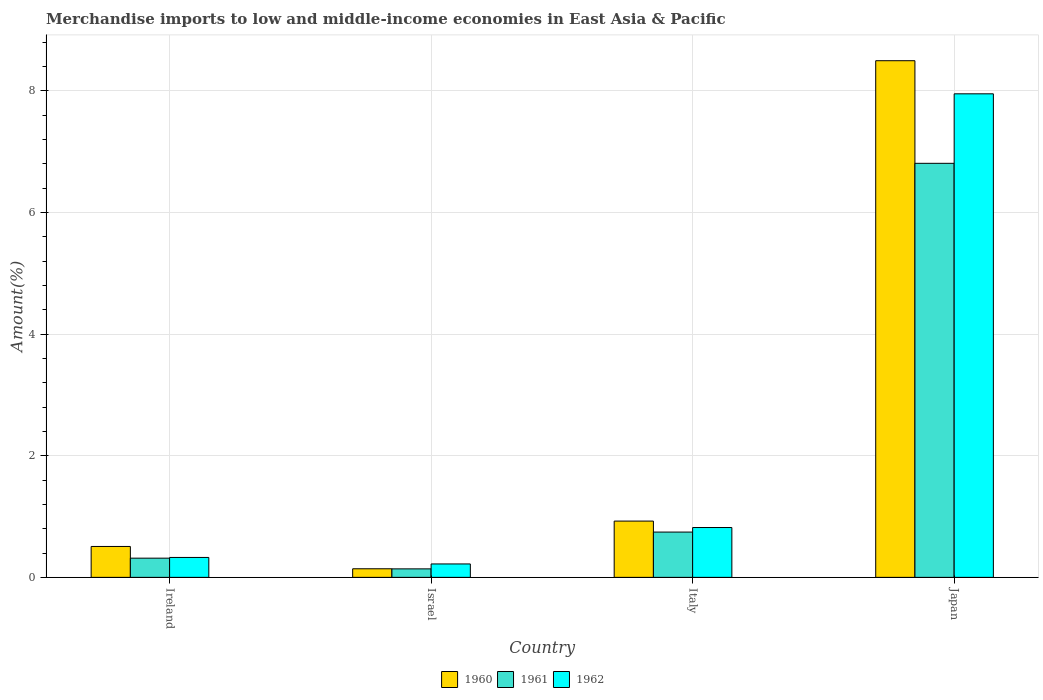How many groups of bars are there?
Offer a terse response. 4. Are the number of bars per tick equal to the number of legend labels?
Your answer should be compact. Yes. How many bars are there on the 4th tick from the left?
Offer a very short reply. 3. How many bars are there on the 1st tick from the right?
Offer a terse response. 3. What is the label of the 1st group of bars from the left?
Offer a terse response. Ireland. In how many cases, is the number of bars for a given country not equal to the number of legend labels?
Offer a terse response. 0. What is the percentage of amount earned from merchandise imports in 1962 in Japan?
Provide a succinct answer. 7.95. Across all countries, what is the maximum percentage of amount earned from merchandise imports in 1962?
Make the answer very short. 7.95. Across all countries, what is the minimum percentage of amount earned from merchandise imports in 1962?
Provide a succinct answer. 0.22. In which country was the percentage of amount earned from merchandise imports in 1961 maximum?
Provide a short and direct response. Japan. What is the total percentage of amount earned from merchandise imports in 1961 in the graph?
Give a very brief answer. 8.01. What is the difference between the percentage of amount earned from merchandise imports in 1962 in Ireland and that in Israel?
Give a very brief answer. 0.11. What is the difference between the percentage of amount earned from merchandise imports in 1960 in Ireland and the percentage of amount earned from merchandise imports in 1961 in Italy?
Give a very brief answer. -0.24. What is the average percentage of amount earned from merchandise imports in 1961 per country?
Ensure brevity in your answer.  2. What is the difference between the percentage of amount earned from merchandise imports of/in 1962 and percentage of amount earned from merchandise imports of/in 1960 in Japan?
Make the answer very short. -0.54. What is the ratio of the percentage of amount earned from merchandise imports in 1960 in Ireland to that in Japan?
Your response must be concise. 0.06. Is the percentage of amount earned from merchandise imports in 1960 in Ireland less than that in Japan?
Provide a succinct answer. Yes. What is the difference between the highest and the second highest percentage of amount earned from merchandise imports in 1961?
Your response must be concise. 0.43. What is the difference between the highest and the lowest percentage of amount earned from merchandise imports in 1961?
Ensure brevity in your answer.  6.67. Is the sum of the percentage of amount earned from merchandise imports in 1960 in Ireland and Japan greater than the maximum percentage of amount earned from merchandise imports in 1962 across all countries?
Ensure brevity in your answer.  Yes. What does the 1st bar from the left in Japan represents?
Provide a succinct answer. 1960. Are all the bars in the graph horizontal?
Give a very brief answer. No. Does the graph contain any zero values?
Give a very brief answer. No. How many legend labels are there?
Keep it short and to the point. 3. How are the legend labels stacked?
Provide a short and direct response. Horizontal. What is the title of the graph?
Your answer should be compact. Merchandise imports to low and middle-income economies in East Asia & Pacific. What is the label or title of the X-axis?
Your answer should be compact. Country. What is the label or title of the Y-axis?
Provide a succinct answer. Amount(%). What is the Amount(%) of 1960 in Ireland?
Keep it short and to the point. 0.51. What is the Amount(%) of 1961 in Ireland?
Offer a terse response. 0.32. What is the Amount(%) of 1962 in Ireland?
Ensure brevity in your answer.  0.33. What is the Amount(%) of 1960 in Israel?
Provide a short and direct response. 0.14. What is the Amount(%) of 1961 in Israel?
Provide a short and direct response. 0.14. What is the Amount(%) in 1962 in Israel?
Offer a very short reply. 0.22. What is the Amount(%) in 1960 in Italy?
Your answer should be very brief. 0.93. What is the Amount(%) of 1961 in Italy?
Provide a short and direct response. 0.74. What is the Amount(%) in 1962 in Italy?
Make the answer very short. 0.82. What is the Amount(%) in 1960 in Japan?
Offer a terse response. 8.5. What is the Amount(%) in 1961 in Japan?
Offer a terse response. 6.81. What is the Amount(%) of 1962 in Japan?
Your answer should be very brief. 7.95. Across all countries, what is the maximum Amount(%) in 1960?
Your answer should be very brief. 8.5. Across all countries, what is the maximum Amount(%) in 1961?
Ensure brevity in your answer.  6.81. Across all countries, what is the maximum Amount(%) of 1962?
Give a very brief answer. 7.95. Across all countries, what is the minimum Amount(%) of 1960?
Keep it short and to the point. 0.14. Across all countries, what is the minimum Amount(%) of 1961?
Give a very brief answer. 0.14. Across all countries, what is the minimum Amount(%) in 1962?
Offer a very short reply. 0.22. What is the total Amount(%) of 1960 in the graph?
Offer a very short reply. 10.07. What is the total Amount(%) in 1961 in the graph?
Give a very brief answer. 8.01. What is the total Amount(%) in 1962 in the graph?
Your response must be concise. 9.32. What is the difference between the Amount(%) in 1960 in Ireland and that in Israel?
Provide a succinct answer. 0.37. What is the difference between the Amount(%) in 1961 in Ireland and that in Israel?
Offer a terse response. 0.18. What is the difference between the Amount(%) of 1962 in Ireland and that in Israel?
Your answer should be compact. 0.11. What is the difference between the Amount(%) in 1960 in Ireland and that in Italy?
Your answer should be compact. -0.42. What is the difference between the Amount(%) of 1961 in Ireland and that in Italy?
Make the answer very short. -0.43. What is the difference between the Amount(%) of 1962 in Ireland and that in Italy?
Keep it short and to the point. -0.49. What is the difference between the Amount(%) of 1960 in Ireland and that in Japan?
Provide a short and direct response. -7.99. What is the difference between the Amount(%) in 1961 in Ireland and that in Japan?
Keep it short and to the point. -6.49. What is the difference between the Amount(%) of 1962 in Ireland and that in Japan?
Provide a succinct answer. -7.62. What is the difference between the Amount(%) in 1960 in Israel and that in Italy?
Give a very brief answer. -0.78. What is the difference between the Amount(%) of 1961 in Israel and that in Italy?
Make the answer very short. -0.6. What is the difference between the Amount(%) of 1962 in Israel and that in Italy?
Offer a very short reply. -0.6. What is the difference between the Amount(%) in 1960 in Israel and that in Japan?
Make the answer very short. -8.35. What is the difference between the Amount(%) in 1961 in Israel and that in Japan?
Your answer should be compact. -6.67. What is the difference between the Amount(%) in 1962 in Israel and that in Japan?
Your response must be concise. -7.73. What is the difference between the Amount(%) in 1960 in Italy and that in Japan?
Offer a very short reply. -7.57. What is the difference between the Amount(%) of 1961 in Italy and that in Japan?
Your response must be concise. -6.06. What is the difference between the Amount(%) in 1962 in Italy and that in Japan?
Keep it short and to the point. -7.13. What is the difference between the Amount(%) in 1960 in Ireland and the Amount(%) in 1961 in Israel?
Your answer should be very brief. 0.37. What is the difference between the Amount(%) in 1960 in Ireland and the Amount(%) in 1962 in Israel?
Ensure brevity in your answer.  0.29. What is the difference between the Amount(%) of 1961 in Ireland and the Amount(%) of 1962 in Israel?
Give a very brief answer. 0.1. What is the difference between the Amount(%) of 1960 in Ireland and the Amount(%) of 1961 in Italy?
Give a very brief answer. -0.24. What is the difference between the Amount(%) of 1960 in Ireland and the Amount(%) of 1962 in Italy?
Provide a short and direct response. -0.31. What is the difference between the Amount(%) in 1961 in Ireland and the Amount(%) in 1962 in Italy?
Your answer should be compact. -0.5. What is the difference between the Amount(%) of 1960 in Ireland and the Amount(%) of 1961 in Japan?
Your answer should be compact. -6.3. What is the difference between the Amount(%) in 1960 in Ireland and the Amount(%) in 1962 in Japan?
Keep it short and to the point. -7.44. What is the difference between the Amount(%) in 1961 in Ireland and the Amount(%) in 1962 in Japan?
Provide a succinct answer. -7.64. What is the difference between the Amount(%) of 1960 in Israel and the Amount(%) of 1961 in Italy?
Your answer should be very brief. -0.6. What is the difference between the Amount(%) of 1960 in Israel and the Amount(%) of 1962 in Italy?
Provide a short and direct response. -0.68. What is the difference between the Amount(%) in 1961 in Israel and the Amount(%) in 1962 in Italy?
Provide a short and direct response. -0.68. What is the difference between the Amount(%) in 1960 in Israel and the Amount(%) in 1961 in Japan?
Your response must be concise. -6.67. What is the difference between the Amount(%) in 1960 in Israel and the Amount(%) in 1962 in Japan?
Offer a very short reply. -7.81. What is the difference between the Amount(%) in 1961 in Israel and the Amount(%) in 1962 in Japan?
Provide a succinct answer. -7.81. What is the difference between the Amount(%) in 1960 in Italy and the Amount(%) in 1961 in Japan?
Provide a succinct answer. -5.88. What is the difference between the Amount(%) in 1960 in Italy and the Amount(%) in 1962 in Japan?
Make the answer very short. -7.03. What is the difference between the Amount(%) in 1961 in Italy and the Amount(%) in 1962 in Japan?
Keep it short and to the point. -7.21. What is the average Amount(%) in 1960 per country?
Offer a terse response. 2.52. What is the average Amount(%) of 1961 per country?
Keep it short and to the point. 2. What is the average Amount(%) of 1962 per country?
Keep it short and to the point. 2.33. What is the difference between the Amount(%) of 1960 and Amount(%) of 1961 in Ireland?
Your answer should be compact. 0.19. What is the difference between the Amount(%) in 1960 and Amount(%) in 1962 in Ireland?
Your answer should be compact. 0.18. What is the difference between the Amount(%) of 1961 and Amount(%) of 1962 in Ireland?
Your answer should be compact. -0.01. What is the difference between the Amount(%) of 1960 and Amount(%) of 1961 in Israel?
Give a very brief answer. 0. What is the difference between the Amount(%) in 1960 and Amount(%) in 1962 in Israel?
Make the answer very short. -0.08. What is the difference between the Amount(%) in 1961 and Amount(%) in 1962 in Israel?
Give a very brief answer. -0.08. What is the difference between the Amount(%) of 1960 and Amount(%) of 1961 in Italy?
Your answer should be compact. 0.18. What is the difference between the Amount(%) of 1960 and Amount(%) of 1962 in Italy?
Offer a terse response. 0.11. What is the difference between the Amount(%) in 1961 and Amount(%) in 1962 in Italy?
Your answer should be compact. -0.07. What is the difference between the Amount(%) in 1960 and Amount(%) in 1961 in Japan?
Provide a succinct answer. 1.69. What is the difference between the Amount(%) of 1960 and Amount(%) of 1962 in Japan?
Provide a succinct answer. 0.54. What is the difference between the Amount(%) of 1961 and Amount(%) of 1962 in Japan?
Ensure brevity in your answer.  -1.14. What is the ratio of the Amount(%) of 1960 in Ireland to that in Israel?
Give a very brief answer. 3.6. What is the ratio of the Amount(%) of 1961 in Ireland to that in Israel?
Ensure brevity in your answer.  2.26. What is the ratio of the Amount(%) of 1962 in Ireland to that in Israel?
Ensure brevity in your answer.  1.48. What is the ratio of the Amount(%) in 1960 in Ireland to that in Italy?
Keep it short and to the point. 0.55. What is the ratio of the Amount(%) of 1961 in Ireland to that in Italy?
Make the answer very short. 0.42. What is the ratio of the Amount(%) of 1962 in Ireland to that in Italy?
Provide a short and direct response. 0.4. What is the ratio of the Amount(%) in 1960 in Ireland to that in Japan?
Provide a short and direct response. 0.06. What is the ratio of the Amount(%) in 1961 in Ireland to that in Japan?
Provide a short and direct response. 0.05. What is the ratio of the Amount(%) in 1962 in Ireland to that in Japan?
Your answer should be compact. 0.04. What is the ratio of the Amount(%) of 1960 in Israel to that in Italy?
Ensure brevity in your answer.  0.15. What is the ratio of the Amount(%) in 1961 in Israel to that in Italy?
Your answer should be very brief. 0.19. What is the ratio of the Amount(%) of 1962 in Israel to that in Italy?
Provide a short and direct response. 0.27. What is the ratio of the Amount(%) of 1960 in Israel to that in Japan?
Your answer should be very brief. 0.02. What is the ratio of the Amount(%) of 1961 in Israel to that in Japan?
Keep it short and to the point. 0.02. What is the ratio of the Amount(%) in 1962 in Israel to that in Japan?
Give a very brief answer. 0.03. What is the ratio of the Amount(%) in 1960 in Italy to that in Japan?
Provide a succinct answer. 0.11. What is the ratio of the Amount(%) of 1961 in Italy to that in Japan?
Provide a short and direct response. 0.11. What is the ratio of the Amount(%) of 1962 in Italy to that in Japan?
Your response must be concise. 0.1. What is the difference between the highest and the second highest Amount(%) in 1960?
Your answer should be compact. 7.57. What is the difference between the highest and the second highest Amount(%) of 1961?
Ensure brevity in your answer.  6.06. What is the difference between the highest and the second highest Amount(%) of 1962?
Make the answer very short. 7.13. What is the difference between the highest and the lowest Amount(%) in 1960?
Ensure brevity in your answer.  8.35. What is the difference between the highest and the lowest Amount(%) in 1961?
Provide a short and direct response. 6.67. What is the difference between the highest and the lowest Amount(%) in 1962?
Offer a terse response. 7.73. 